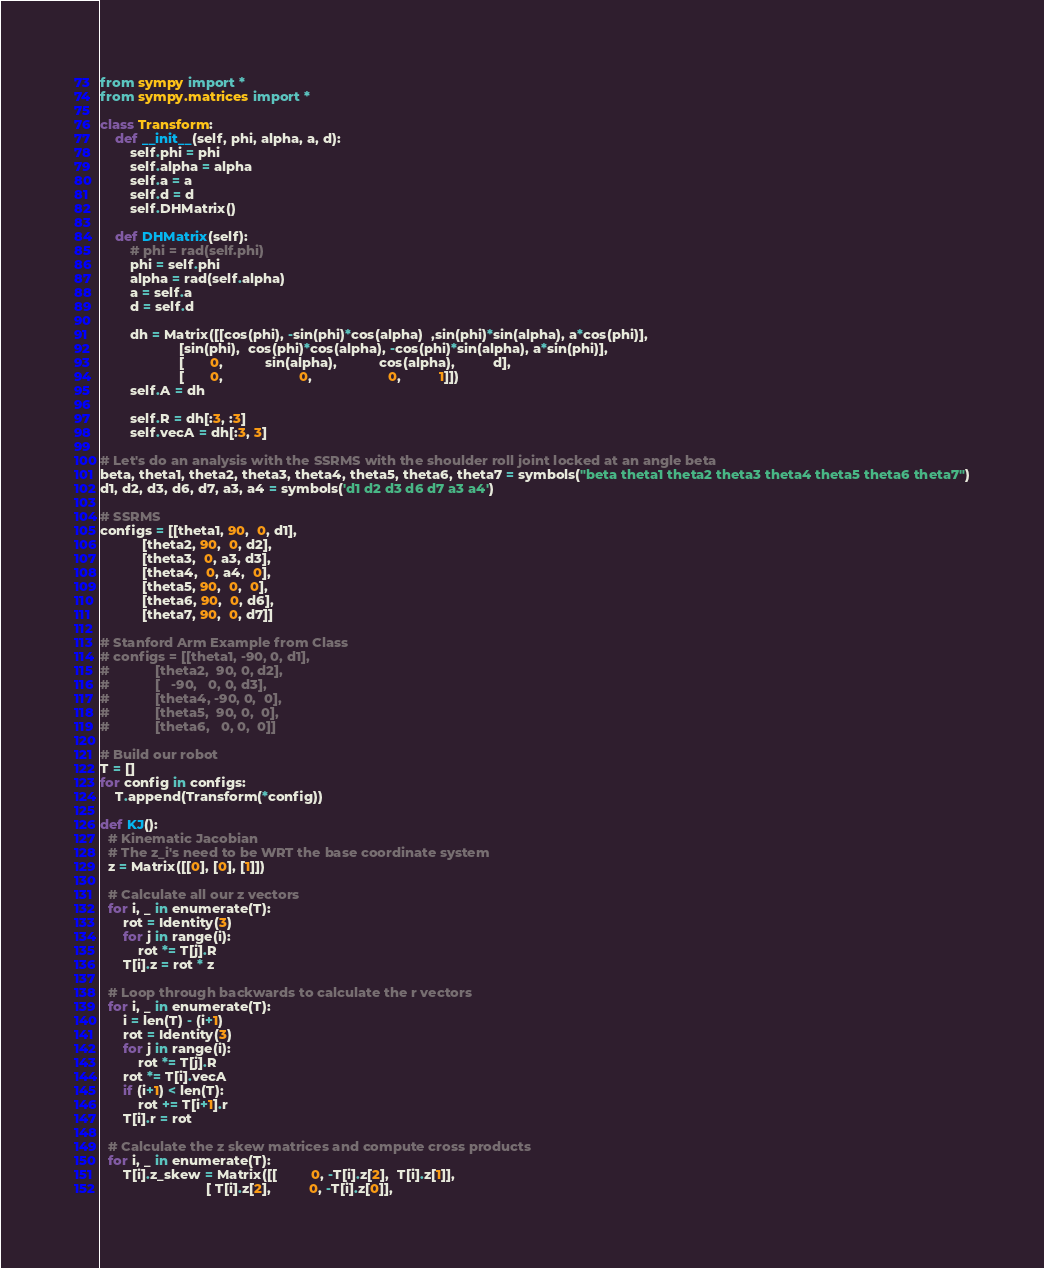<code> <loc_0><loc_0><loc_500><loc_500><_Python_>from sympy import *
from sympy.matrices import *

class Transform:
    def __init__(self, phi, alpha, a, d):
        self.phi = phi
        self.alpha = alpha
        self.a = a
        self.d = d
        self.DHMatrix()

    def DHMatrix(self):
        # phi = rad(self.phi)
        phi = self.phi
        alpha = rad(self.alpha)
        a = self.a
        d = self.d

        dh = Matrix([[cos(phi), -sin(phi)*cos(alpha)  ,sin(phi)*sin(alpha), a*cos(phi)],
                     [sin(phi),  cos(phi)*cos(alpha), -cos(phi)*sin(alpha), a*sin(phi)],
                     [       0,           sin(alpha),           cos(alpha),          d],
                     [       0,                    0,                    0,          1]])
        self.A = dh

        self.R = dh[:3, :3]
        self.vecA = dh[:3, 3]

# Let's do an analysis with the SSRMS with the shoulder roll joint locked at an angle beta
beta, theta1, theta2, theta3, theta4, theta5, theta6, theta7 = symbols("beta theta1 theta2 theta3 theta4 theta5 theta6 theta7")
d1, d2, d3, d6, d7, a3, a4 = symbols('d1 d2 d3 d6 d7 a3 a4')

# SSRMS
configs = [[theta1, 90,  0, d1],
           [theta2, 90,  0, d2],
           [theta3,  0, a3, d3],
           [theta4,  0, a4,  0],
           [theta5, 90,  0,  0],
           [theta6, 90,  0, d6],
           [theta7, 90,  0, d7]]

# Stanford Arm Example from Class
# configs = [[theta1, -90, 0, d1],
#            [theta2,  90, 0, d2],
#            [   -90,   0, 0, d3],
#            [theta4, -90, 0,  0],
#            [theta5,  90, 0,  0],
#            [theta6,   0, 0,  0]]

# Build our robot
T = []
for config in configs:
    T.append(Transform(*config))

def KJ():
  # Kinematic Jacobian
  # The z_i's need to be WRT the base coordinate system
  z = Matrix([[0], [0], [1]])

  # Calculate all our z vectors
  for i, _ in enumerate(T):
      rot = Identity(3)
      for j in range(i):
          rot *= T[j].R
      T[i].z = rot * z

  # Loop through backwards to calculate the r vectors
  for i, _ in enumerate(T):
      i = len(T) - (i+1)
      rot = Identity(3)
      for j in range(i):
          rot *= T[j].R
      rot *= T[i].vecA
      if (i+1) < len(T):
          rot += T[i+1].r
      T[i].r = rot

  # Calculate the z skew matrices and compute cross products
  for i, _ in enumerate(T):
      T[i].z_skew = Matrix([[         0, -T[i].z[2],  T[i].z[1]],
                            [ T[i].z[2],          0, -T[i].z[0]],</code> 